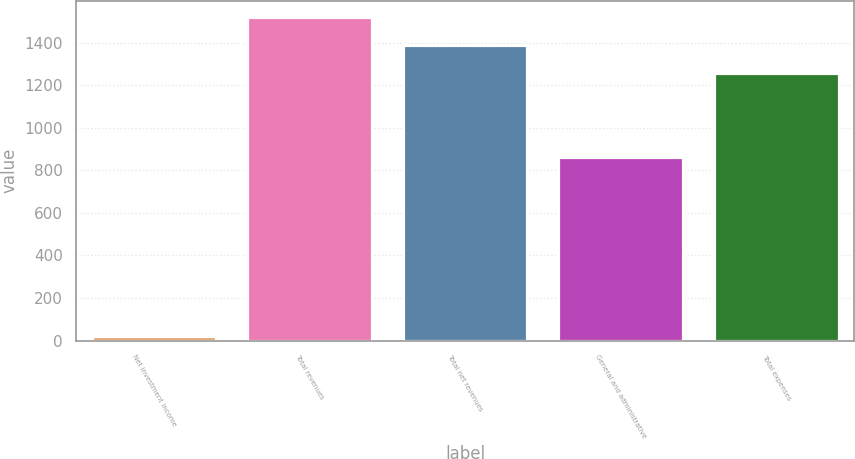Convert chart. <chart><loc_0><loc_0><loc_500><loc_500><bar_chart><fcel>Net investment income<fcel>Total revenues<fcel>Total net revenues<fcel>General and administrative<fcel>Total expenses<nl><fcel>21<fcel>1522<fcel>1389<fcel>864<fcel>1256<nl></chart> 